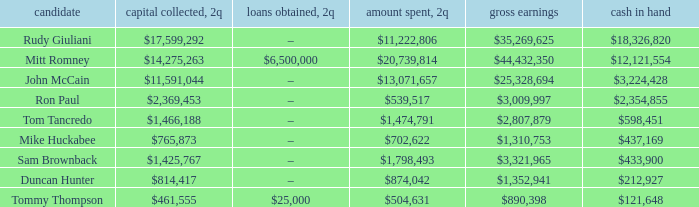Could you parse the entire table as a dict? {'header': ['candidate', 'capital collected, 2q', 'loans obtained, 2q', 'amount spent, 2q', 'gross earnings', 'cash in hand'], 'rows': [['Rudy Giuliani', '$17,599,292', '–', '$11,222,806', '$35,269,625', '$18,326,820'], ['Mitt Romney', '$14,275,263', '$6,500,000', '$20,739,814', '$44,432,350', '$12,121,554'], ['John McCain', '$11,591,044', '–', '$13,071,657', '$25,328,694', '$3,224,428'], ['Ron Paul', '$2,369,453', '–', '$539,517', '$3,009,997', '$2,354,855'], ['Tom Tancredo', '$1,466,188', '–', '$1,474,791', '$2,807,879', '$598,451'], ['Mike Huckabee', '$765,873', '–', '$702,622', '$1,310,753', '$437,169'], ['Sam Brownback', '$1,425,767', '–', '$1,798,493', '$3,321,965', '$433,900'], ['Duncan Hunter', '$814,417', '–', '$874,042', '$1,352,941', '$212,927'], ['Tommy Thompson', '$461,555', '$25,000', '$504,631', '$890,398', '$121,648']]} Tell me the total receipts for tom tancredo $2,807,879. 